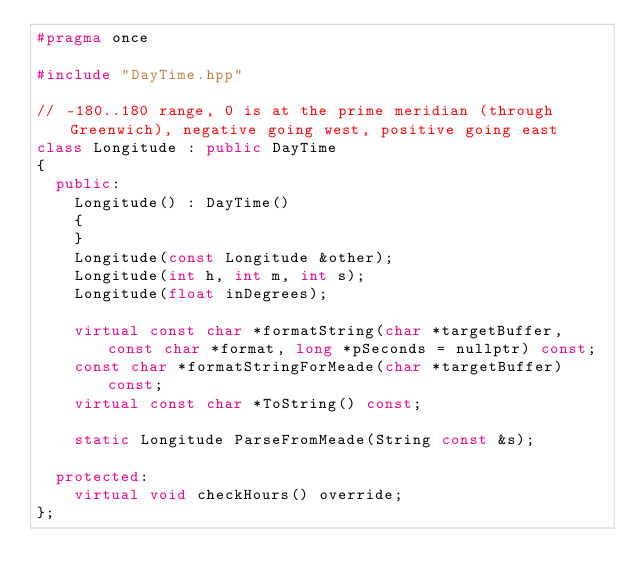Convert code to text. <code><loc_0><loc_0><loc_500><loc_500><_C++_>#pragma once

#include "DayTime.hpp"

// -180..180 range, 0 is at the prime meridian (through Greenwich), negative going west, positive going east
class Longitude : public DayTime
{
  public:
    Longitude() : DayTime()
    {
    }
    Longitude(const Longitude &other);
    Longitude(int h, int m, int s);
    Longitude(float inDegrees);

    virtual const char *formatString(char *targetBuffer, const char *format, long *pSeconds = nullptr) const;
    const char *formatStringForMeade(char *targetBuffer) const;
    virtual const char *ToString() const;

    static Longitude ParseFromMeade(String const &s);

  protected:
    virtual void checkHours() override;
};
</code> 